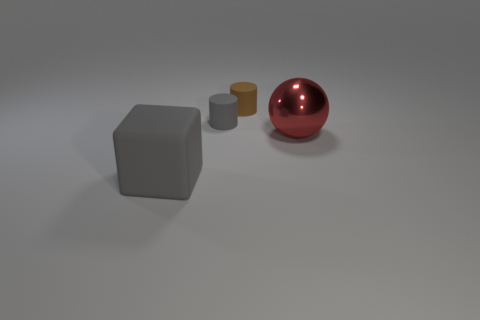Does the brown object have the same shape as the small gray object? Yes, both the brown and the small gray object share a cylindrical shape, each having a circular base and straight parallel sides. However, the brown cylinder is larger in both height and diameter compared to the small gray one. 